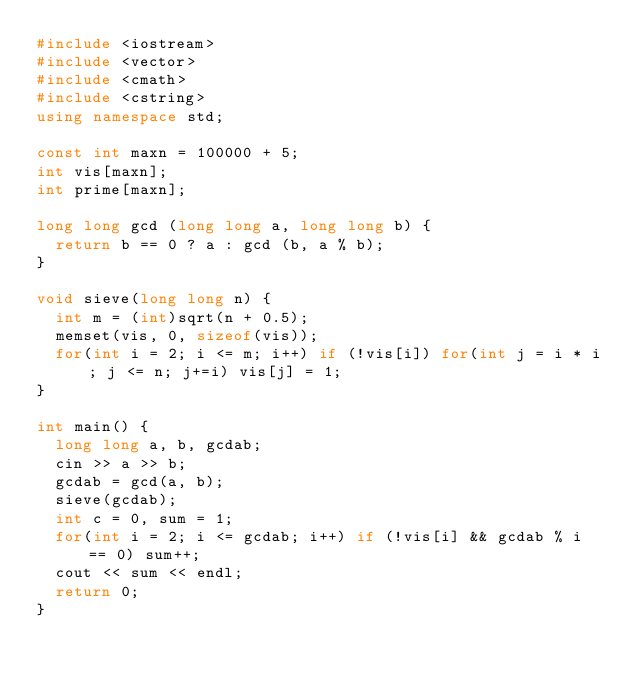<code> <loc_0><loc_0><loc_500><loc_500><_C++_>#include <iostream>
#include <vector>
#include <cmath>
#include <cstring>
using namespace std;

const int maxn = 100000 + 5;
int vis[maxn];
int prime[maxn];

long long gcd (long long a, long long b) {
	return b == 0 ? a : gcd (b, a % b);
}

void sieve(long long n) {
	int m = (int)sqrt(n + 0.5);
	memset(vis, 0, sizeof(vis));
	for(int i = 2; i <= m; i++) if (!vis[i]) for(int j = i * i; j <= n; j+=i) vis[j] = 1;
}

int main() {
	long long a, b, gcdab;
	cin >> a >> b;
	gcdab = gcd(a, b);
	sieve(gcdab);
	int c = 0, sum = 1;
	for(int i = 2; i <= gcdab; i++) if (!vis[i] && gcdab % i == 0) sum++;
	cout << sum << endl;
	return 0;
}</code> 